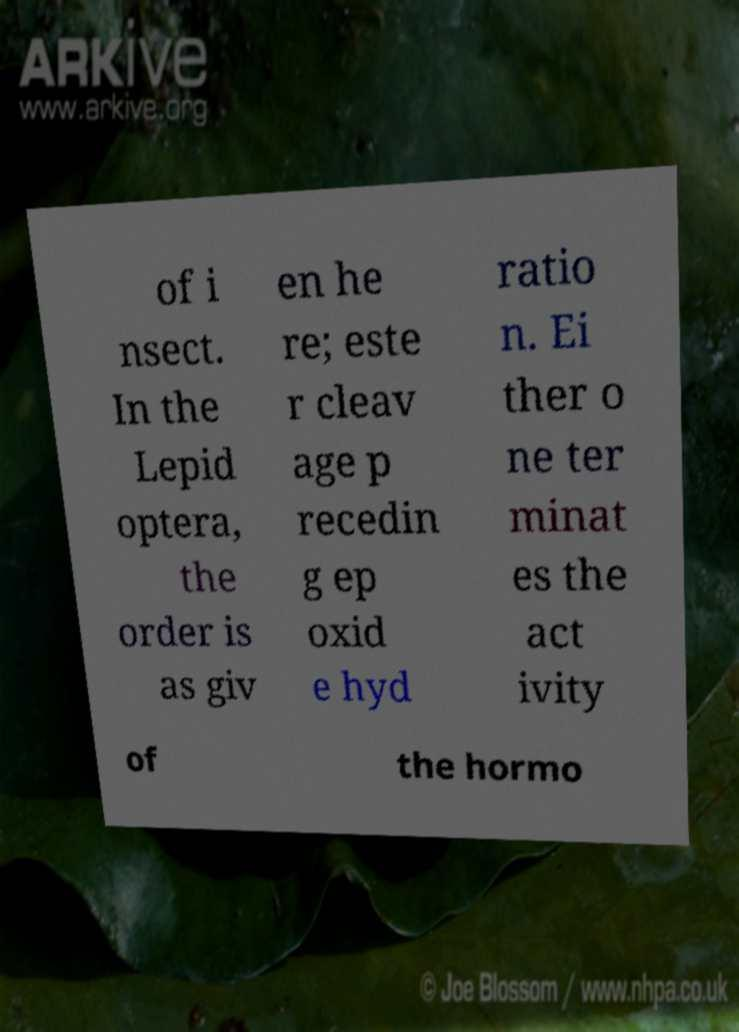There's text embedded in this image that I need extracted. Can you transcribe it verbatim? of i nsect. In the Lepid optera, the order is as giv en he re; este r cleav age p recedin g ep oxid e hyd ratio n. Ei ther o ne ter minat es the act ivity of the hormo 